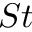<formula> <loc_0><loc_0><loc_500><loc_500>S t</formula> 